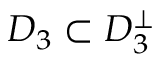Convert formula to latex. <formula><loc_0><loc_0><loc_500><loc_500>D _ { 3 } \subset D _ { 3 } ^ { \bot }</formula> 